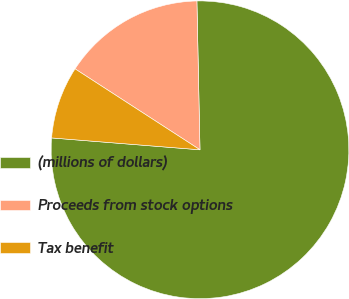<chart> <loc_0><loc_0><loc_500><loc_500><pie_chart><fcel>(millions of dollars)<fcel>Proceeds from stock options<fcel>Tax benefit<nl><fcel>76.6%<fcel>15.52%<fcel>7.88%<nl></chart> 